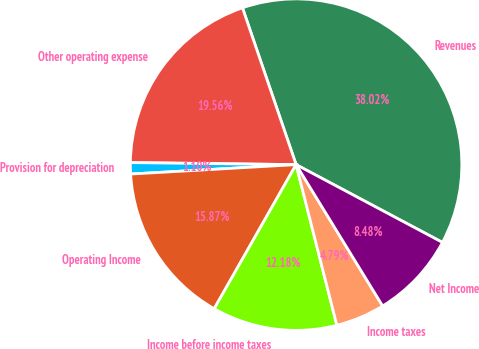Convert chart to OTSL. <chart><loc_0><loc_0><loc_500><loc_500><pie_chart><fcel>Revenues<fcel>Other operating expense<fcel>Provision for depreciation<fcel>Operating Income<fcel>Income before income taxes<fcel>Income taxes<fcel>Net Income<nl><fcel>38.02%<fcel>19.56%<fcel>1.1%<fcel>15.87%<fcel>12.18%<fcel>4.79%<fcel>8.48%<nl></chart> 